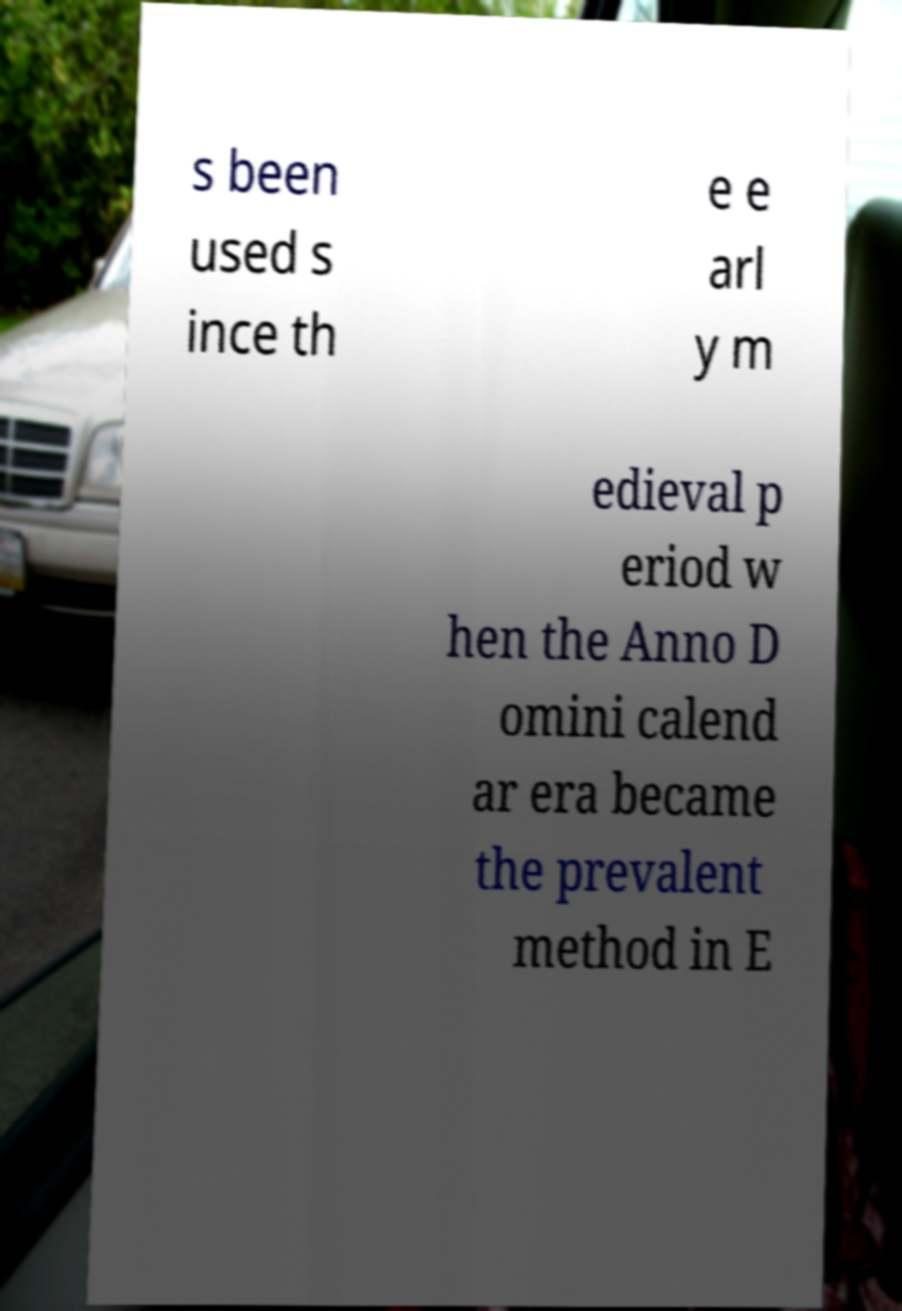What messages or text are displayed in this image? I need them in a readable, typed format. s been used s ince th e e arl y m edieval p eriod w hen the Anno D omini calend ar era became the prevalent method in E 